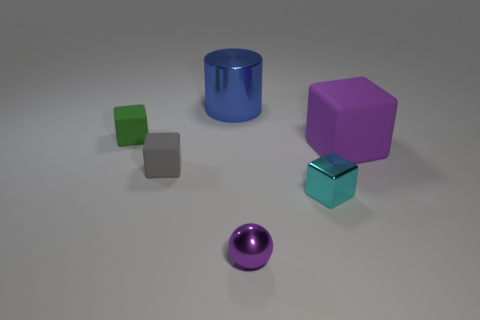What number of things are green rubber cylinders or shiny things?
Your answer should be very brief. 3. How many shiny objects are behind the small matte block that is in front of the purple cube?
Your answer should be compact. 1. How many other objects are the same size as the cyan metal thing?
Offer a very short reply. 3. What is the size of the object that is the same color as the shiny sphere?
Offer a terse response. Large. There is a small object behind the tiny gray cube; does it have the same shape as the large purple rubber object?
Offer a very short reply. Yes. There is a object on the left side of the tiny gray matte thing; what is it made of?
Keep it short and to the point. Rubber. There is a tiny shiny object that is the same color as the large matte block; what is its shape?
Your answer should be compact. Sphere. Is there a tiny sphere that has the same material as the purple block?
Your response must be concise. No. How big is the gray matte block?
Your answer should be very brief. Small. What number of brown objects are either cubes or metallic objects?
Keep it short and to the point. 0. 